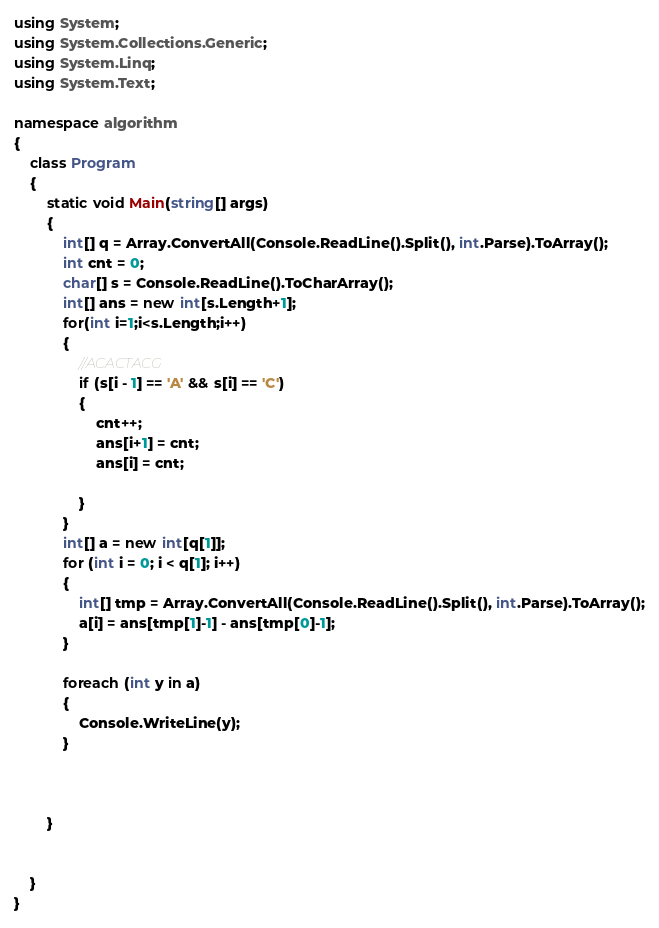<code> <loc_0><loc_0><loc_500><loc_500><_C#_>using System;
using System.Collections.Generic;
using System.Linq;
using System.Text;

namespace algorithm
{
	class Program
	{
		static void Main(string[] args)
		{
			int[] q = Array.ConvertAll(Console.ReadLine().Split(), int.Parse).ToArray();
			int cnt = 0;
			char[] s = Console.ReadLine().ToCharArray();
			int[] ans = new int[s.Length+1];
			for(int i=1;i<s.Length;i++)
			{
				//ACACTACG
				if (s[i - 1] == 'A' && s[i] == 'C')
				{
					cnt++;
					ans[i+1] = cnt;
					ans[i] = cnt;

				}
			}
			int[] a = new int[q[1]];
			for (int i = 0; i < q[1]; i++)
			{
				int[] tmp = Array.ConvertAll(Console.ReadLine().Split(), int.Parse).ToArray();
				a[i] = ans[tmp[1]-1] - ans[tmp[0]-1];
			}

			foreach (int y in a)
			{
				Console.WriteLine(y);
			}



		}
		
			
	}
}

</code> 